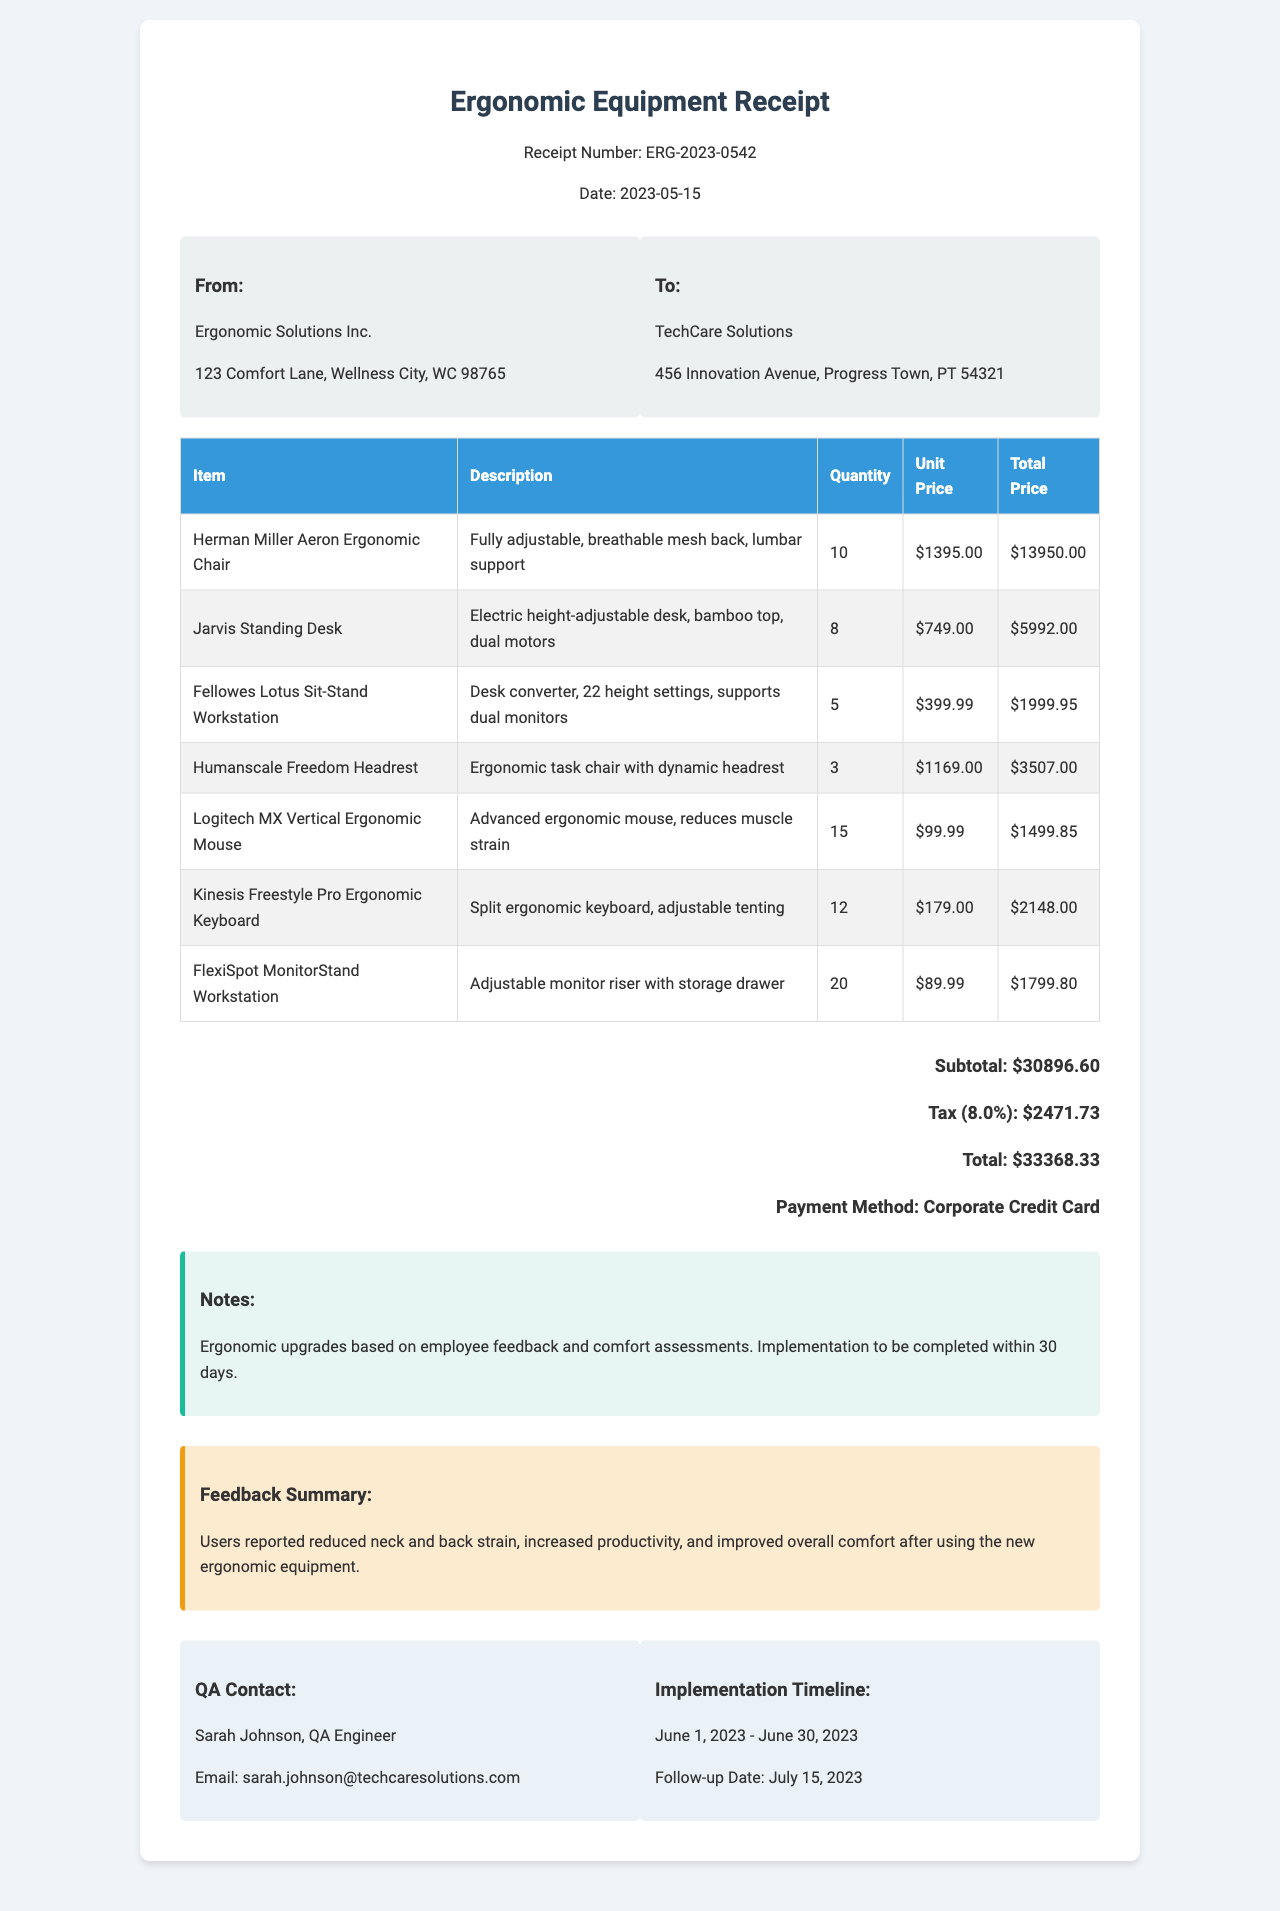What is the receipt number? The receipt number is a unique identifier for this transaction.
Answer: ERG-2023-0542 Who is the customer? The customer is the entity receiving the ergonomic equipment as indicated in the document.
Answer: TechCare Solutions What is the total amount due? The total amount is the final figure that includes all items, tax, and any additional charges.
Answer: $33,368.33 How many Herman Miller Aeron chairs were purchased? The quantity purchased for each item is detailed in the document.
Answer: 10 What was reported in the feedback summary? The feedback summary provides qualitative insights from users regarding the ergonomic upgrades.
Answer: Users reported reduced neck and back strain, increased productivity, and improved overall comfort after using the new ergonomic equipment What is the payment method used? The payment method indicates how the transaction was settled in this receipt.
Answer: Corporate Credit Card What is the implementation timeline? The implementation timeline provides specific dates for when the equipment is to be implemented.
Answer: June 1, 2023 - June 30, 2023 How many adjustable standing desks were bought? The quantity for each item shows how many units were acquired in this transaction.
Answer: 8 Who is the QA contact person? The QA contact is the individual responsible for addressing any quality assurance issues related to the equipment.
Answer: Sarah Johnson 